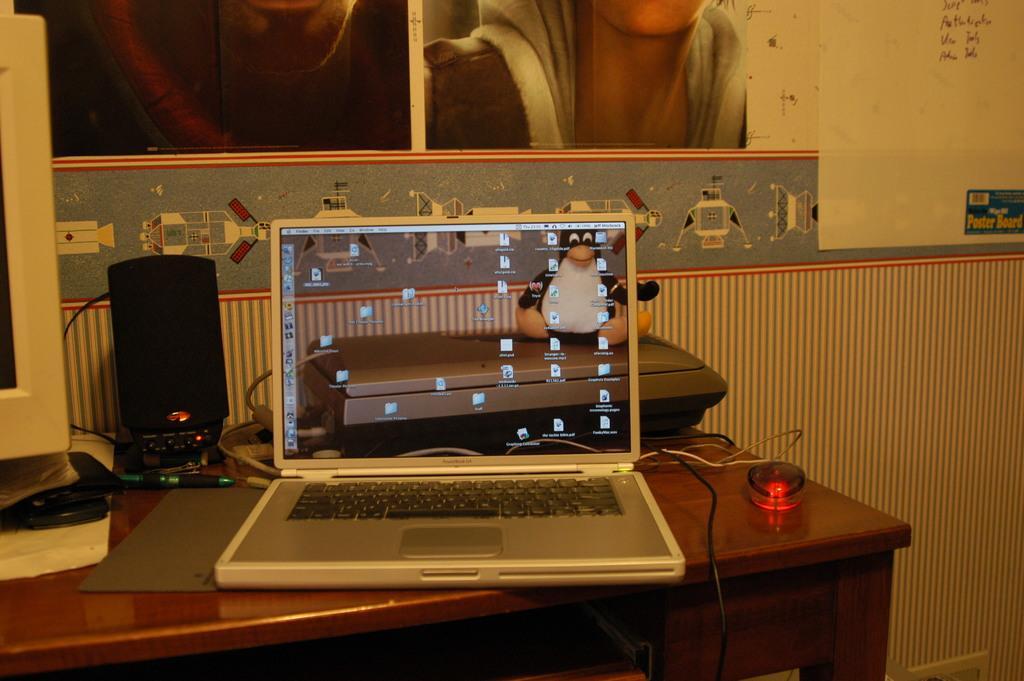Could you give a brief overview of what you see in this image? In this picture we can see laptop, mouse, wired, speakers, pen, monitor on table and in background we can see wall with poster. 